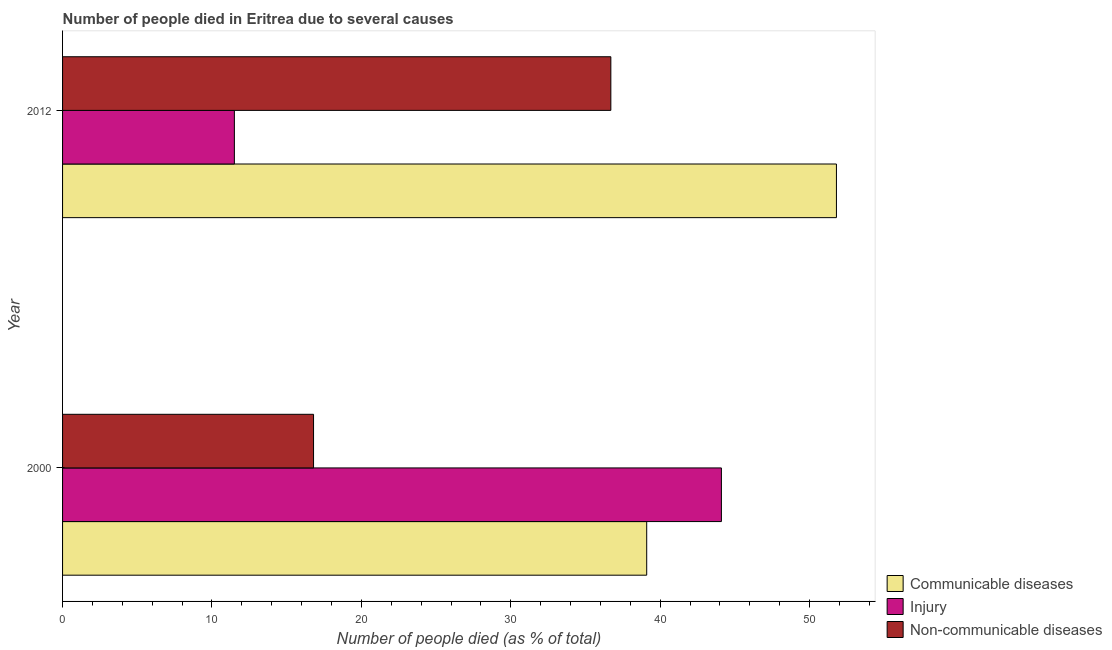How many different coloured bars are there?
Offer a very short reply. 3. How many groups of bars are there?
Make the answer very short. 2. Are the number of bars per tick equal to the number of legend labels?
Offer a very short reply. Yes. How many bars are there on the 1st tick from the top?
Offer a terse response. 3. How many bars are there on the 1st tick from the bottom?
Give a very brief answer. 3. What is the number of people who dies of non-communicable diseases in 2012?
Offer a very short reply. 36.7. Across all years, what is the maximum number of people who died of communicable diseases?
Your response must be concise. 51.8. Across all years, what is the minimum number of people who died of injury?
Offer a terse response. 11.5. In which year was the number of people who dies of non-communicable diseases minimum?
Keep it short and to the point. 2000. What is the total number of people who dies of non-communicable diseases in the graph?
Provide a succinct answer. 53.5. What is the difference between the number of people who dies of non-communicable diseases in 2000 and that in 2012?
Make the answer very short. -19.9. What is the difference between the number of people who died of injury in 2000 and the number of people who dies of non-communicable diseases in 2012?
Provide a succinct answer. 7.4. What is the average number of people who dies of non-communicable diseases per year?
Provide a succinct answer. 26.75. In the year 2012, what is the difference between the number of people who dies of non-communicable diseases and number of people who died of injury?
Provide a succinct answer. 25.2. In how many years, is the number of people who died of injury greater than 52 %?
Offer a terse response. 0. What is the ratio of the number of people who died of injury in 2000 to that in 2012?
Provide a short and direct response. 3.83. Is the number of people who dies of non-communicable diseases in 2000 less than that in 2012?
Make the answer very short. Yes. What does the 1st bar from the top in 2012 represents?
Make the answer very short. Non-communicable diseases. What does the 3rd bar from the bottom in 2012 represents?
Make the answer very short. Non-communicable diseases. Is it the case that in every year, the sum of the number of people who died of communicable diseases and number of people who died of injury is greater than the number of people who dies of non-communicable diseases?
Give a very brief answer. Yes. How many bars are there?
Your response must be concise. 6. Are all the bars in the graph horizontal?
Provide a short and direct response. Yes. How many years are there in the graph?
Keep it short and to the point. 2. What is the difference between two consecutive major ticks on the X-axis?
Ensure brevity in your answer.  10. Does the graph contain grids?
Your response must be concise. No. Where does the legend appear in the graph?
Your response must be concise. Bottom right. What is the title of the graph?
Give a very brief answer. Number of people died in Eritrea due to several causes. What is the label or title of the X-axis?
Your response must be concise. Number of people died (as % of total). What is the label or title of the Y-axis?
Offer a terse response. Year. What is the Number of people died (as % of total) in Communicable diseases in 2000?
Your response must be concise. 39.1. What is the Number of people died (as % of total) of Injury in 2000?
Offer a terse response. 44.1. What is the Number of people died (as % of total) in Communicable diseases in 2012?
Your response must be concise. 51.8. What is the Number of people died (as % of total) of Non-communicable diseases in 2012?
Your answer should be compact. 36.7. Across all years, what is the maximum Number of people died (as % of total) in Communicable diseases?
Offer a very short reply. 51.8. Across all years, what is the maximum Number of people died (as % of total) in Injury?
Keep it short and to the point. 44.1. Across all years, what is the maximum Number of people died (as % of total) in Non-communicable diseases?
Offer a very short reply. 36.7. Across all years, what is the minimum Number of people died (as % of total) in Communicable diseases?
Your response must be concise. 39.1. What is the total Number of people died (as % of total) of Communicable diseases in the graph?
Provide a short and direct response. 90.9. What is the total Number of people died (as % of total) in Injury in the graph?
Give a very brief answer. 55.6. What is the total Number of people died (as % of total) in Non-communicable diseases in the graph?
Offer a terse response. 53.5. What is the difference between the Number of people died (as % of total) in Injury in 2000 and that in 2012?
Ensure brevity in your answer.  32.6. What is the difference between the Number of people died (as % of total) of Non-communicable diseases in 2000 and that in 2012?
Ensure brevity in your answer.  -19.9. What is the difference between the Number of people died (as % of total) of Communicable diseases in 2000 and the Number of people died (as % of total) of Injury in 2012?
Give a very brief answer. 27.6. What is the average Number of people died (as % of total) of Communicable diseases per year?
Offer a terse response. 45.45. What is the average Number of people died (as % of total) in Injury per year?
Offer a very short reply. 27.8. What is the average Number of people died (as % of total) in Non-communicable diseases per year?
Ensure brevity in your answer.  26.75. In the year 2000, what is the difference between the Number of people died (as % of total) in Communicable diseases and Number of people died (as % of total) in Non-communicable diseases?
Give a very brief answer. 22.3. In the year 2000, what is the difference between the Number of people died (as % of total) of Injury and Number of people died (as % of total) of Non-communicable diseases?
Ensure brevity in your answer.  27.3. In the year 2012, what is the difference between the Number of people died (as % of total) in Communicable diseases and Number of people died (as % of total) in Injury?
Give a very brief answer. 40.3. In the year 2012, what is the difference between the Number of people died (as % of total) of Communicable diseases and Number of people died (as % of total) of Non-communicable diseases?
Your answer should be very brief. 15.1. In the year 2012, what is the difference between the Number of people died (as % of total) in Injury and Number of people died (as % of total) in Non-communicable diseases?
Your response must be concise. -25.2. What is the ratio of the Number of people died (as % of total) in Communicable diseases in 2000 to that in 2012?
Your answer should be very brief. 0.75. What is the ratio of the Number of people died (as % of total) in Injury in 2000 to that in 2012?
Give a very brief answer. 3.83. What is the ratio of the Number of people died (as % of total) of Non-communicable diseases in 2000 to that in 2012?
Your response must be concise. 0.46. What is the difference between the highest and the second highest Number of people died (as % of total) in Communicable diseases?
Provide a succinct answer. 12.7. What is the difference between the highest and the second highest Number of people died (as % of total) in Injury?
Offer a terse response. 32.6. What is the difference between the highest and the lowest Number of people died (as % of total) of Injury?
Your response must be concise. 32.6. What is the difference between the highest and the lowest Number of people died (as % of total) in Non-communicable diseases?
Provide a succinct answer. 19.9. 